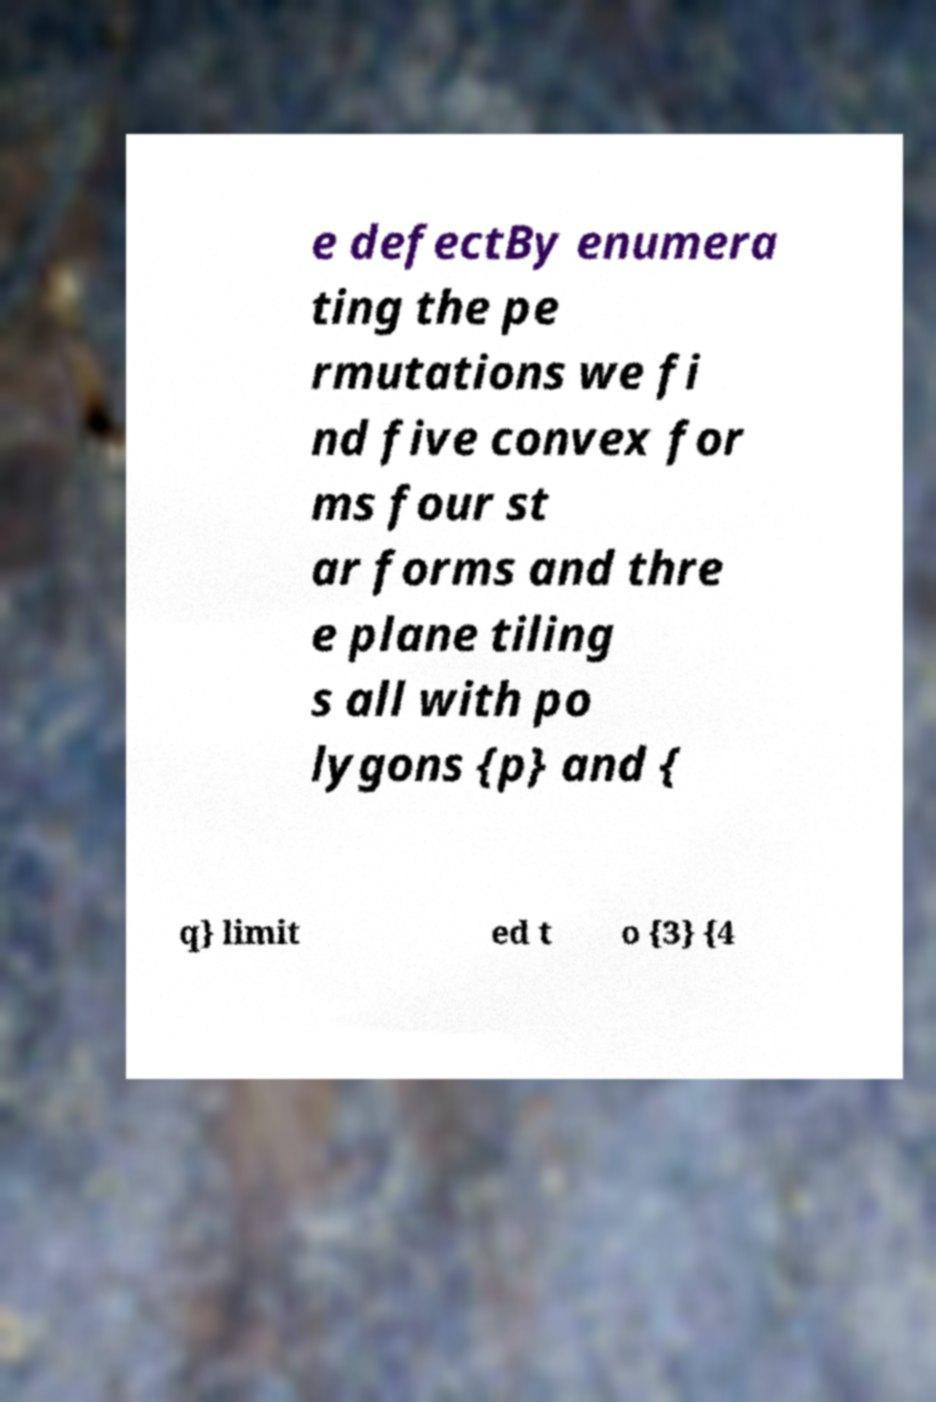Could you extract and type out the text from this image? e defectBy enumera ting the pe rmutations we fi nd five convex for ms four st ar forms and thre e plane tiling s all with po lygons {p} and { q} limit ed t o {3} {4 